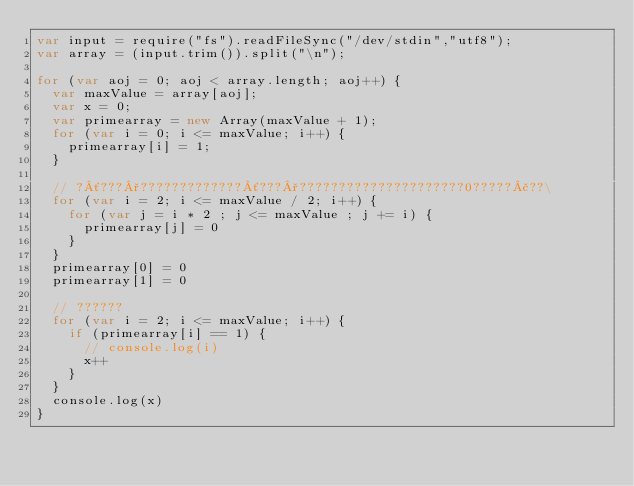Convert code to text. <code><loc_0><loc_0><loc_500><loc_500><_JavaScript_>var input = require("fs").readFileSync("/dev/stdin","utf8");
var array = (input.trim()).split("\n");

for (var aoj = 0; aoj < array.length; aoj++) {
  var maxValue = array[aoj];
  var x = 0;
  var primearray = new Array(maxValue + 1);
  for (var i = 0; i <= maxValue; i++) {
    primearray[i] = 1;
  }

  // ?´???°?????????????´???°?????????????????????0?????£??\
  for (var i = 2; i <= maxValue / 2; i++) {
    for (var j = i * 2 ; j <= maxValue ; j += i) {
      primearray[j] = 0
    }
  }
  primearray[0] = 0
  primearray[1] = 0

  // ??????
  for (var i = 2; i <= maxValue; i++) {
    if (primearray[i] == 1) {
      // console.log(i)
      x++
    }
  }
  console.log(x)
}</code> 